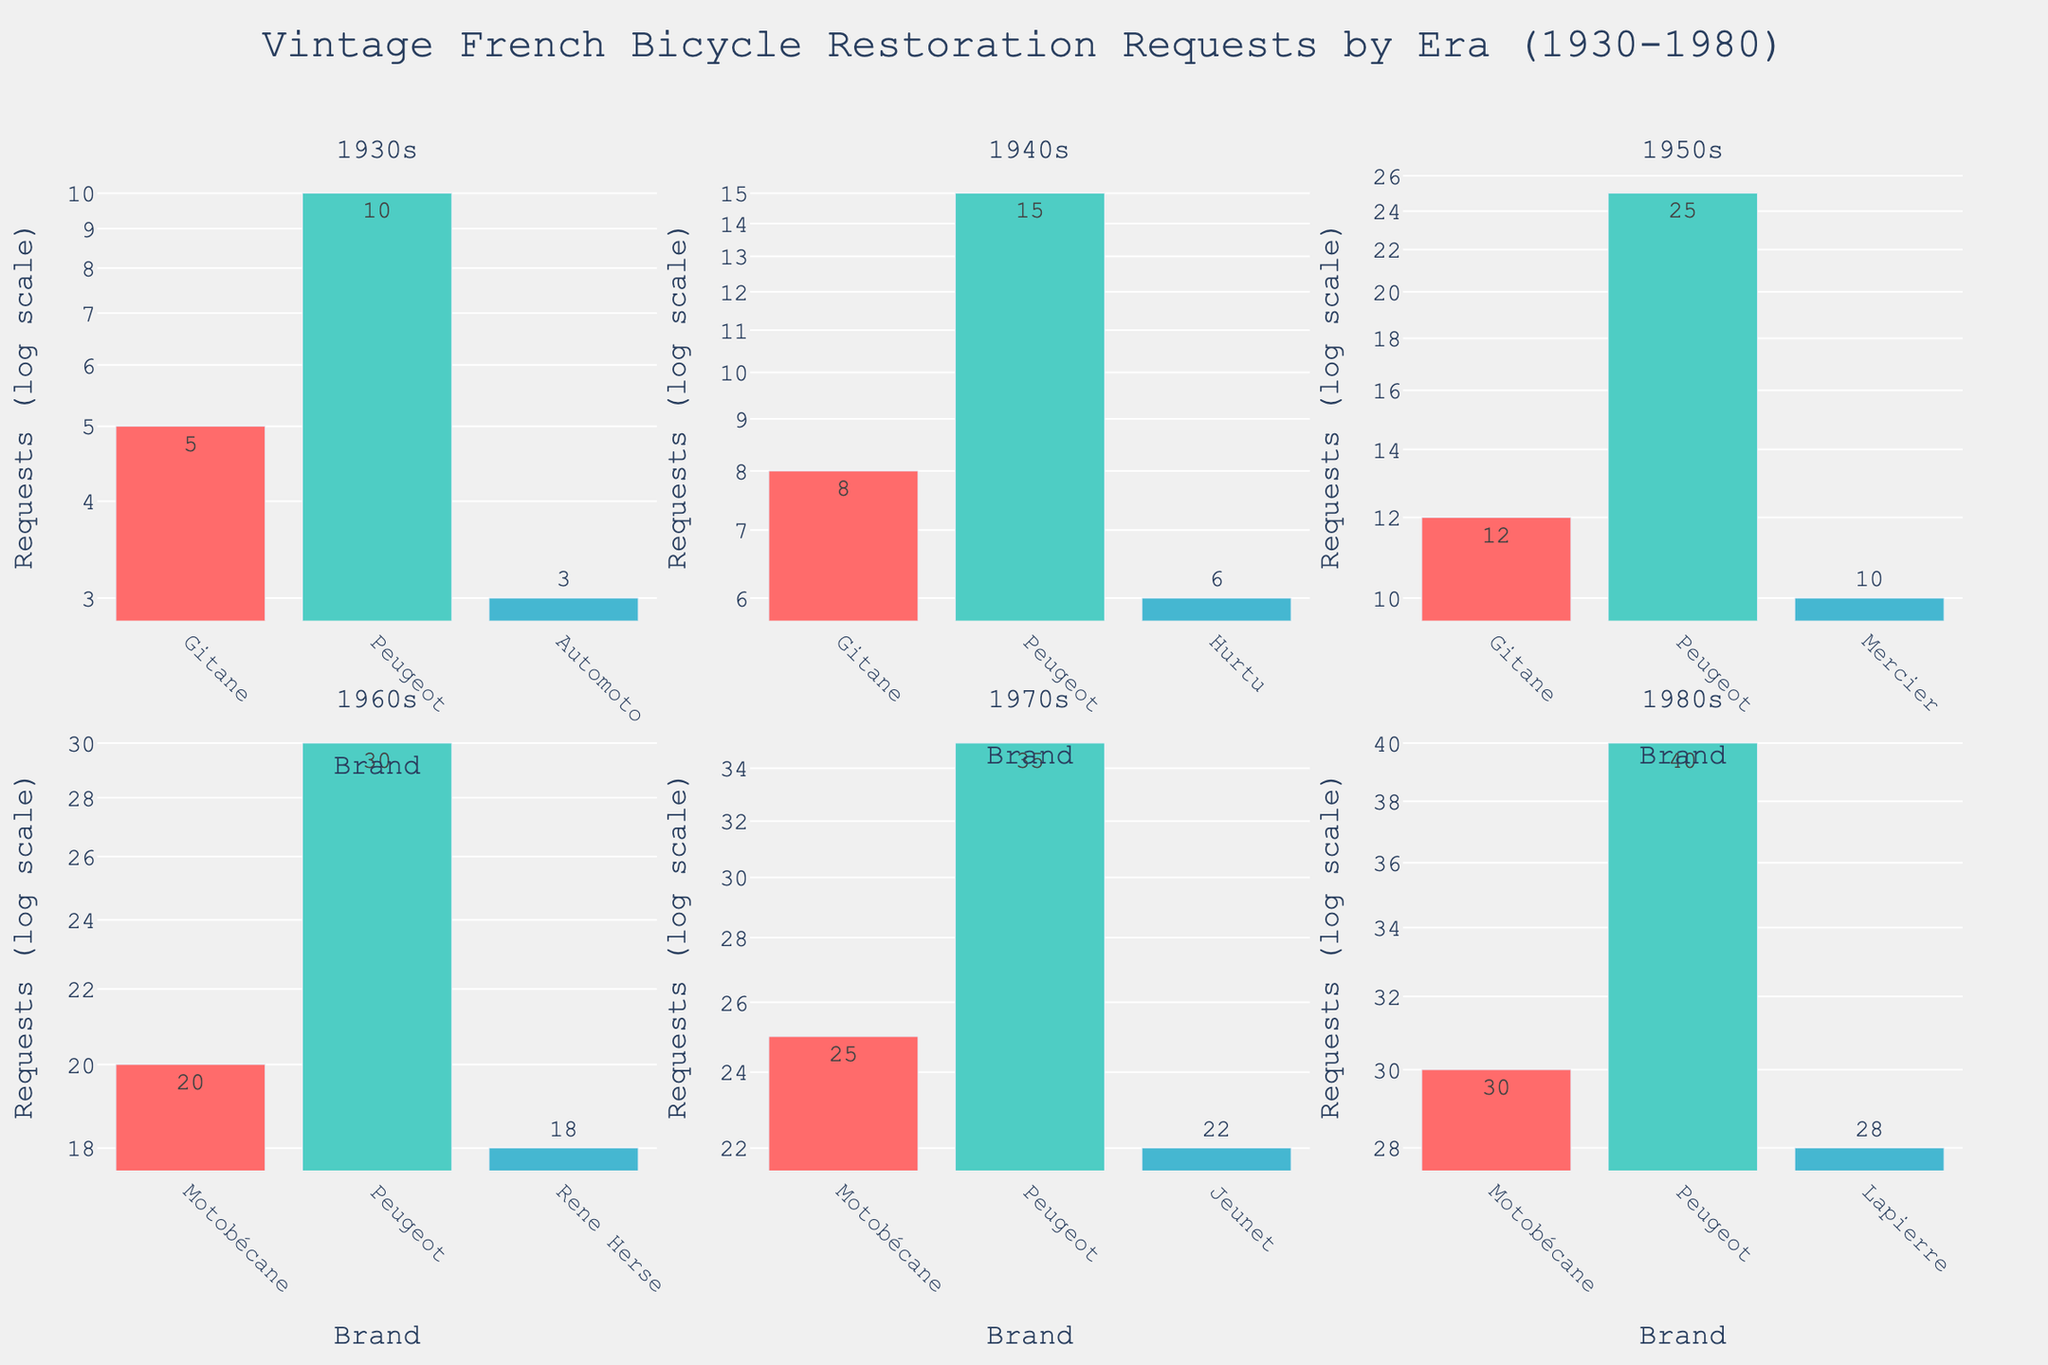what is the title of the figure? The title is usually found at the top of the figure and summarizes the main topic of the data being shown. In this case, the title is located at the top center.
Answer: Vintage French Bicycle Restoration Requests by Era (1930-1980) which era has the highest number of restoration requests for a single brand? By looking at each subplot for different eras and comparing the heights of the bars on the log scale, the 1980s era has the highest number of requests for a single brand, which is Peugeot with 40 requests.
Answer: 1980s how many brands are represented in the 1950s era subplot? By counting the number of unique brands (bars) in the subplot labeled for the 1950s era, there are 3 brands represented.
Answer: 3 which brand had the most restoration requests in the 1930s era, and how many? By examining the heights of the bars for the 1930s era subplot, Peugeot had the most restoration requests, with a value of 10.
Answer: Peugeot, 10 compare the restoration requests for Gitane in the 1940s and 1950s; which decade has more, and by how many? By referencing the bars for Gitane in the 1940s and 1950s subplots, the 1950s had 12 requests, and the 1940s had 8 requests. The difference is 12 - 8 = 4.
Answer: 1950s, 4 calculate the total number of restoration requests for Motobécane across all eras. Add the number of restoration requests for Motobécane in each era: 20 (1960s) + 25 (1970s) + 30 (1980s) = 75.
Answer: 75 which era shows the largest variation in restoration requests among brands, and why? The largest variation can be identified through the range from the highest to the lowest bar in each era's subplot. The 1980s era has the highest variation with Peugeot at 40 requests and Lapierre at 28 requests, creating a more significant range than any other era.
Answer: 1980s which subplot has the all unique brands never repeated in any other subplot? By comparing the brands listed in each era's subplot, the 1960s subplot has all unique brands (Motobécane, Peugeot, Rene Herse) that do not repeat in any other era.
Answer: 1960s what is the second most requested brand for restoration in the 1970s era? By examining the heights of the bars for the 1970s era subplot, the second-highest bar represents Jeunet with 22 requests, right after Peugeot with 35.
Answer: Jeunet how do the restoration requests compare between the oldest (1930s) and the newest (1980s) eras for Peugeot? By comparing the bar heights for Peugeot in the 1930s and 1980s subplots, 10 requests in the 1930s and 40 requests in the 1980s, the newest era has significantly more requests by 30.
Answer: 1980s, 30 